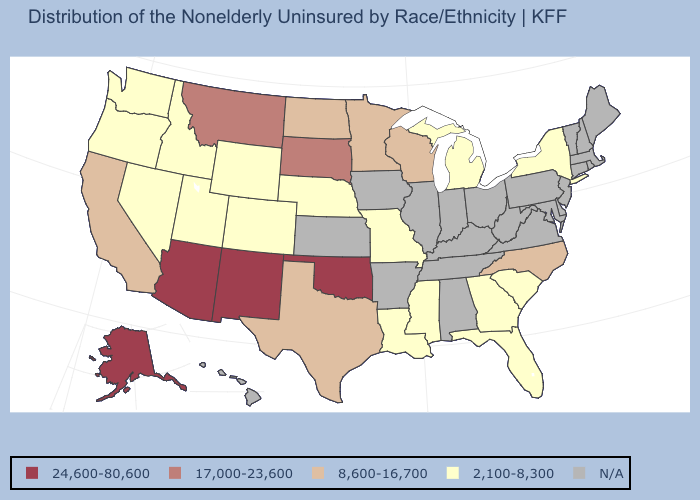Does Florida have the lowest value in the USA?
Short answer required. Yes. What is the lowest value in the USA?
Concise answer only. 2,100-8,300. What is the value of Pennsylvania?
Concise answer only. N/A. What is the value of Indiana?
Write a very short answer. N/A. What is the lowest value in the South?
Write a very short answer. 2,100-8,300. Does New York have the highest value in the USA?
Concise answer only. No. What is the lowest value in the USA?
Answer briefly. 2,100-8,300. Which states hav the highest value in the South?
Give a very brief answer. Oklahoma. What is the lowest value in the USA?
Answer briefly. 2,100-8,300. Does Mississippi have the highest value in the USA?
Short answer required. No. What is the value of Maine?
Write a very short answer. N/A. How many symbols are there in the legend?
Be succinct. 5. What is the value of Kentucky?
Quick response, please. N/A. What is the value of New Hampshire?
Concise answer only. N/A. Does Oklahoma have the highest value in the South?
Concise answer only. Yes. 